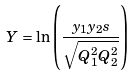Convert formula to latex. <formula><loc_0><loc_0><loc_500><loc_500>Y = \ln \left ( \frac { y _ { 1 } y _ { 2 } s } { \sqrt { Q _ { 1 } ^ { 2 } Q _ { 2 } ^ { 2 } } } \right )</formula> 